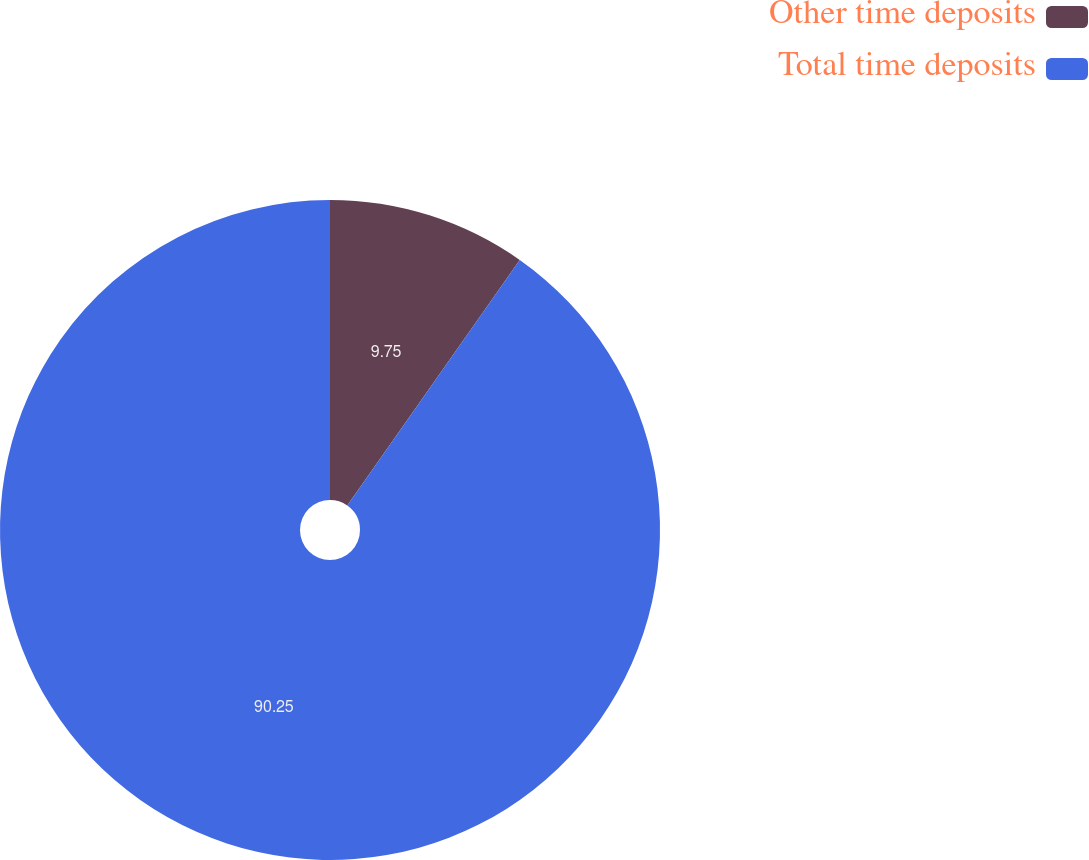Convert chart. <chart><loc_0><loc_0><loc_500><loc_500><pie_chart><fcel>Other time deposits<fcel>Total time deposits<nl><fcel>9.75%<fcel>90.25%<nl></chart> 